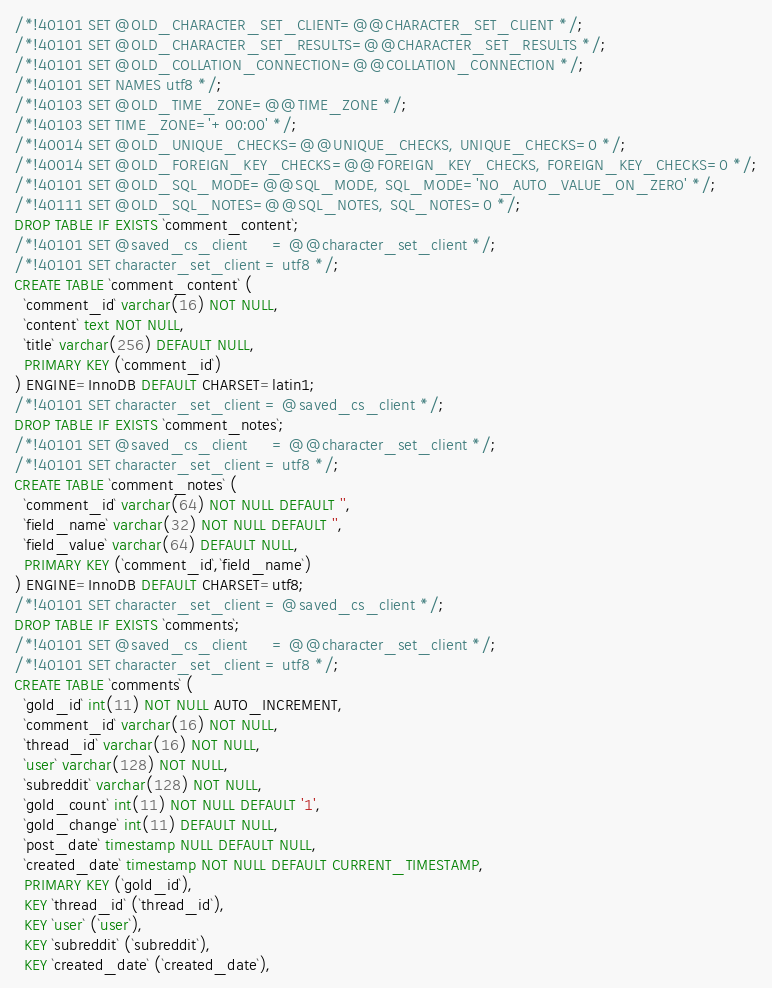Convert code to text. <code><loc_0><loc_0><loc_500><loc_500><_SQL_>
/*!40101 SET @OLD_CHARACTER_SET_CLIENT=@@CHARACTER_SET_CLIENT */;
/*!40101 SET @OLD_CHARACTER_SET_RESULTS=@@CHARACTER_SET_RESULTS */;
/*!40101 SET @OLD_COLLATION_CONNECTION=@@COLLATION_CONNECTION */;
/*!40101 SET NAMES utf8 */;
/*!40103 SET @OLD_TIME_ZONE=@@TIME_ZONE */;
/*!40103 SET TIME_ZONE='+00:00' */;
/*!40014 SET @OLD_UNIQUE_CHECKS=@@UNIQUE_CHECKS, UNIQUE_CHECKS=0 */;
/*!40014 SET @OLD_FOREIGN_KEY_CHECKS=@@FOREIGN_KEY_CHECKS, FOREIGN_KEY_CHECKS=0 */;
/*!40101 SET @OLD_SQL_MODE=@@SQL_MODE, SQL_MODE='NO_AUTO_VALUE_ON_ZERO' */;
/*!40111 SET @OLD_SQL_NOTES=@@SQL_NOTES, SQL_NOTES=0 */;
DROP TABLE IF EXISTS `comment_content`;
/*!40101 SET @saved_cs_client     = @@character_set_client */;
/*!40101 SET character_set_client = utf8 */;
CREATE TABLE `comment_content` (
  `comment_id` varchar(16) NOT NULL,
  `content` text NOT NULL,
  `title` varchar(256) DEFAULT NULL,
  PRIMARY KEY (`comment_id`)
) ENGINE=InnoDB DEFAULT CHARSET=latin1;
/*!40101 SET character_set_client = @saved_cs_client */;
DROP TABLE IF EXISTS `comment_notes`;
/*!40101 SET @saved_cs_client     = @@character_set_client */;
/*!40101 SET character_set_client = utf8 */;
CREATE TABLE `comment_notes` (
  `comment_id` varchar(64) NOT NULL DEFAULT '',
  `field_name` varchar(32) NOT NULL DEFAULT '',
  `field_value` varchar(64) DEFAULT NULL,
  PRIMARY KEY (`comment_id`,`field_name`)
) ENGINE=InnoDB DEFAULT CHARSET=utf8;
/*!40101 SET character_set_client = @saved_cs_client */;
DROP TABLE IF EXISTS `comments`;
/*!40101 SET @saved_cs_client     = @@character_set_client */;
/*!40101 SET character_set_client = utf8 */;
CREATE TABLE `comments` (
  `gold_id` int(11) NOT NULL AUTO_INCREMENT,
  `comment_id` varchar(16) NOT NULL,
  `thread_id` varchar(16) NOT NULL,
  `user` varchar(128) NOT NULL,
  `subreddit` varchar(128) NOT NULL,
  `gold_count` int(11) NOT NULL DEFAULT '1',
  `gold_change` int(11) DEFAULT NULL,
  `post_date` timestamp NULL DEFAULT NULL,
  `created_date` timestamp NOT NULL DEFAULT CURRENT_TIMESTAMP,
  PRIMARY KEY (`gold_id`),
  KEY `thread_id` (`thread_id`),
  KEY `user` (`user`),
  KEY `subreddit` (`subreddit`),
  KEY `created_date` (`created_date`),</code> 